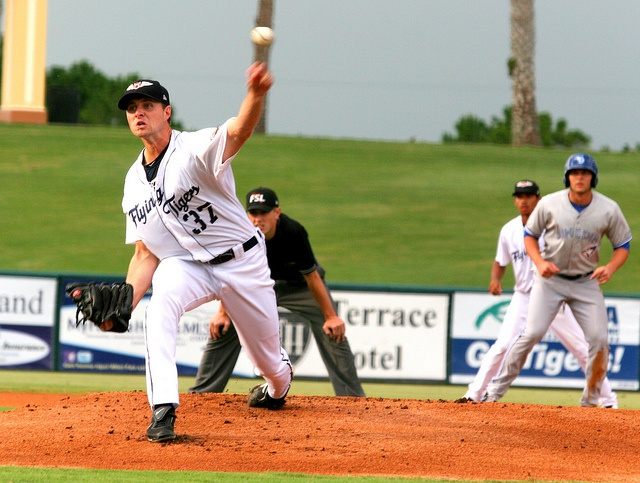Describe the objects in this image and their specific colors. I can see people in gray, lavender, black, darkgray, and salmon tones, people in gray, darkgray, and lightgray tones, people in gray, black, and maroon tones, people in gray, white, lightpink, black, and brown tones, and baseball glove in gray, black, and maroon tones in this image. 